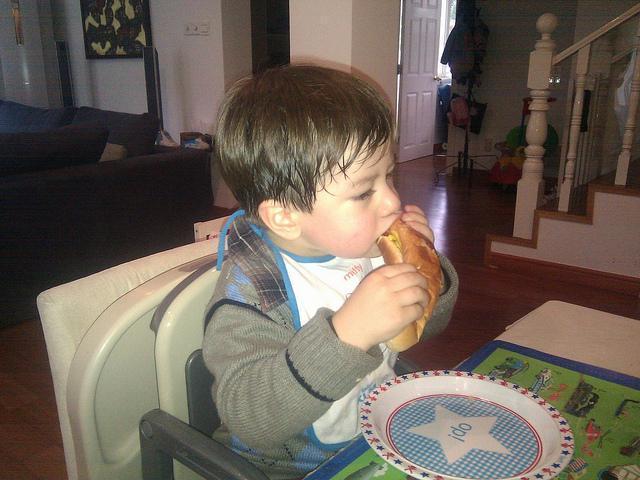Does the description: "The person is touching the sandwich." accurately reflect the image?
Answer yes or no. Yes. Is the caption "The couch is beneath the sandwich." a true representation of the image?
Answer yes or no. No. 